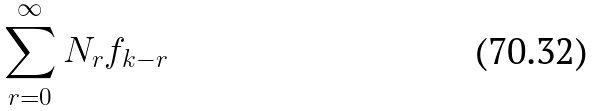<formula> <loc_0><loc_0><loc_500><loc_500>\sum _ { r = 0 } ^ { \infty } N _ { r } f _ { k - r }</formula> 